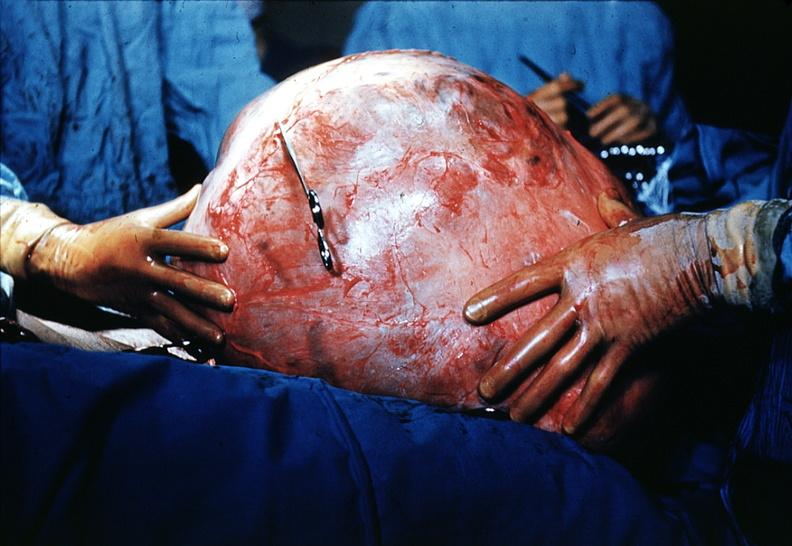s female reproductive present?
Answer the question using a single word or phrase. Yes 